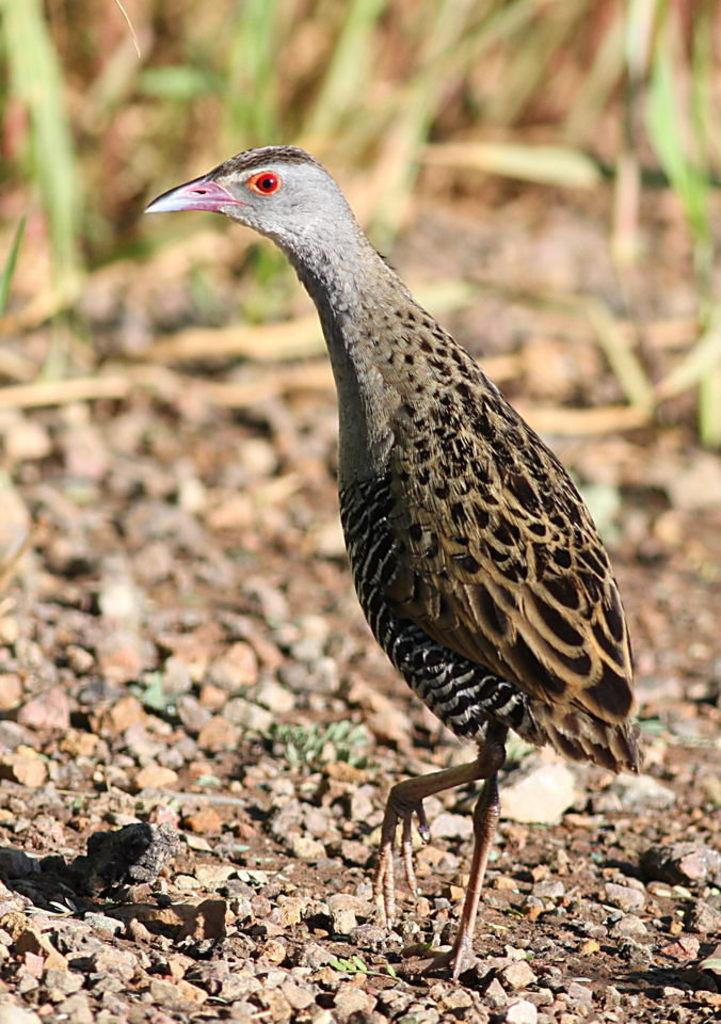What type of animal can be seen in the picture? There is a bird in the picture. Can you describe the bird's appearance? The bird has brown feathers and a beak. What is on the floor in the picture? There are stones on the floor. What can be seen in the background of the picture? There is grass visible in the background. What type of coil can be seen in the bird's beak in the image? There is no coil present in the image; the bird has a beak, but it is not holding any coil. 